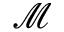Convert formula to latex. <formula><loc_0><loc_0><loc_500><loc_500>\mathcal { M }</formula> 